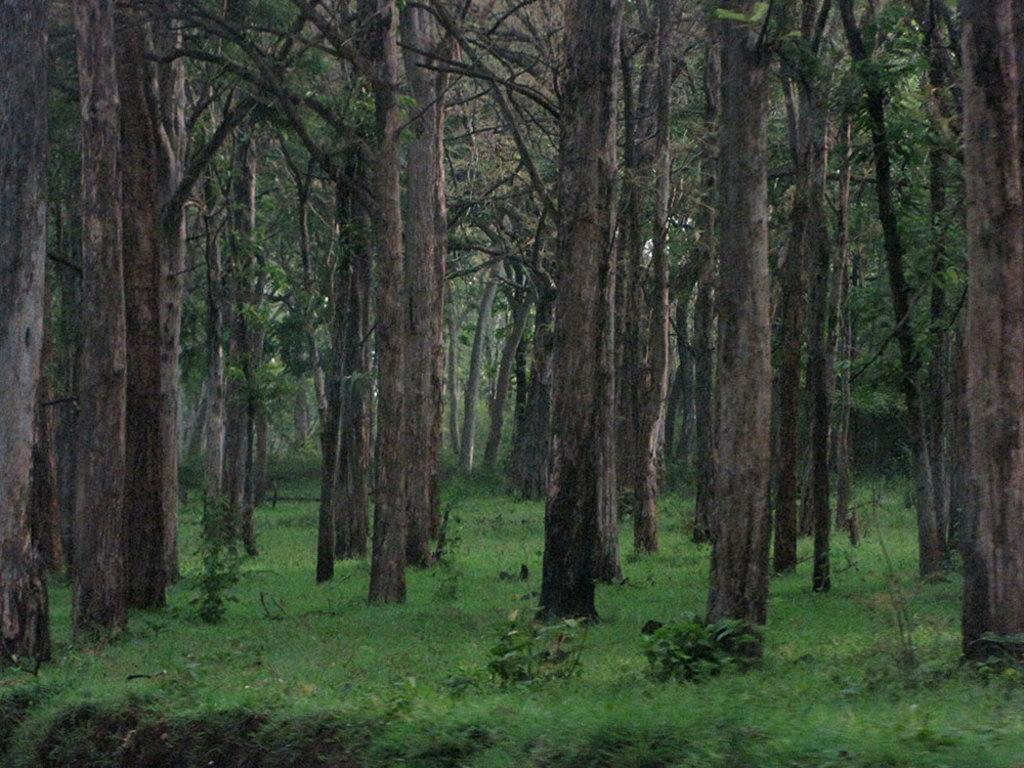What type of vegetation can be seen in the image? There are trees and plants in the image. What is covering the ground in the image? There is grass on the ground in the image. What type of chalk is being used to draw on the trees in the image? There is no chalk or drawing present in the image; it features trees, plants, and grass. Can you tell me how many bears are sitting on the grass in the image? There are no bears present in the image; it features trees, plants, and grass. 